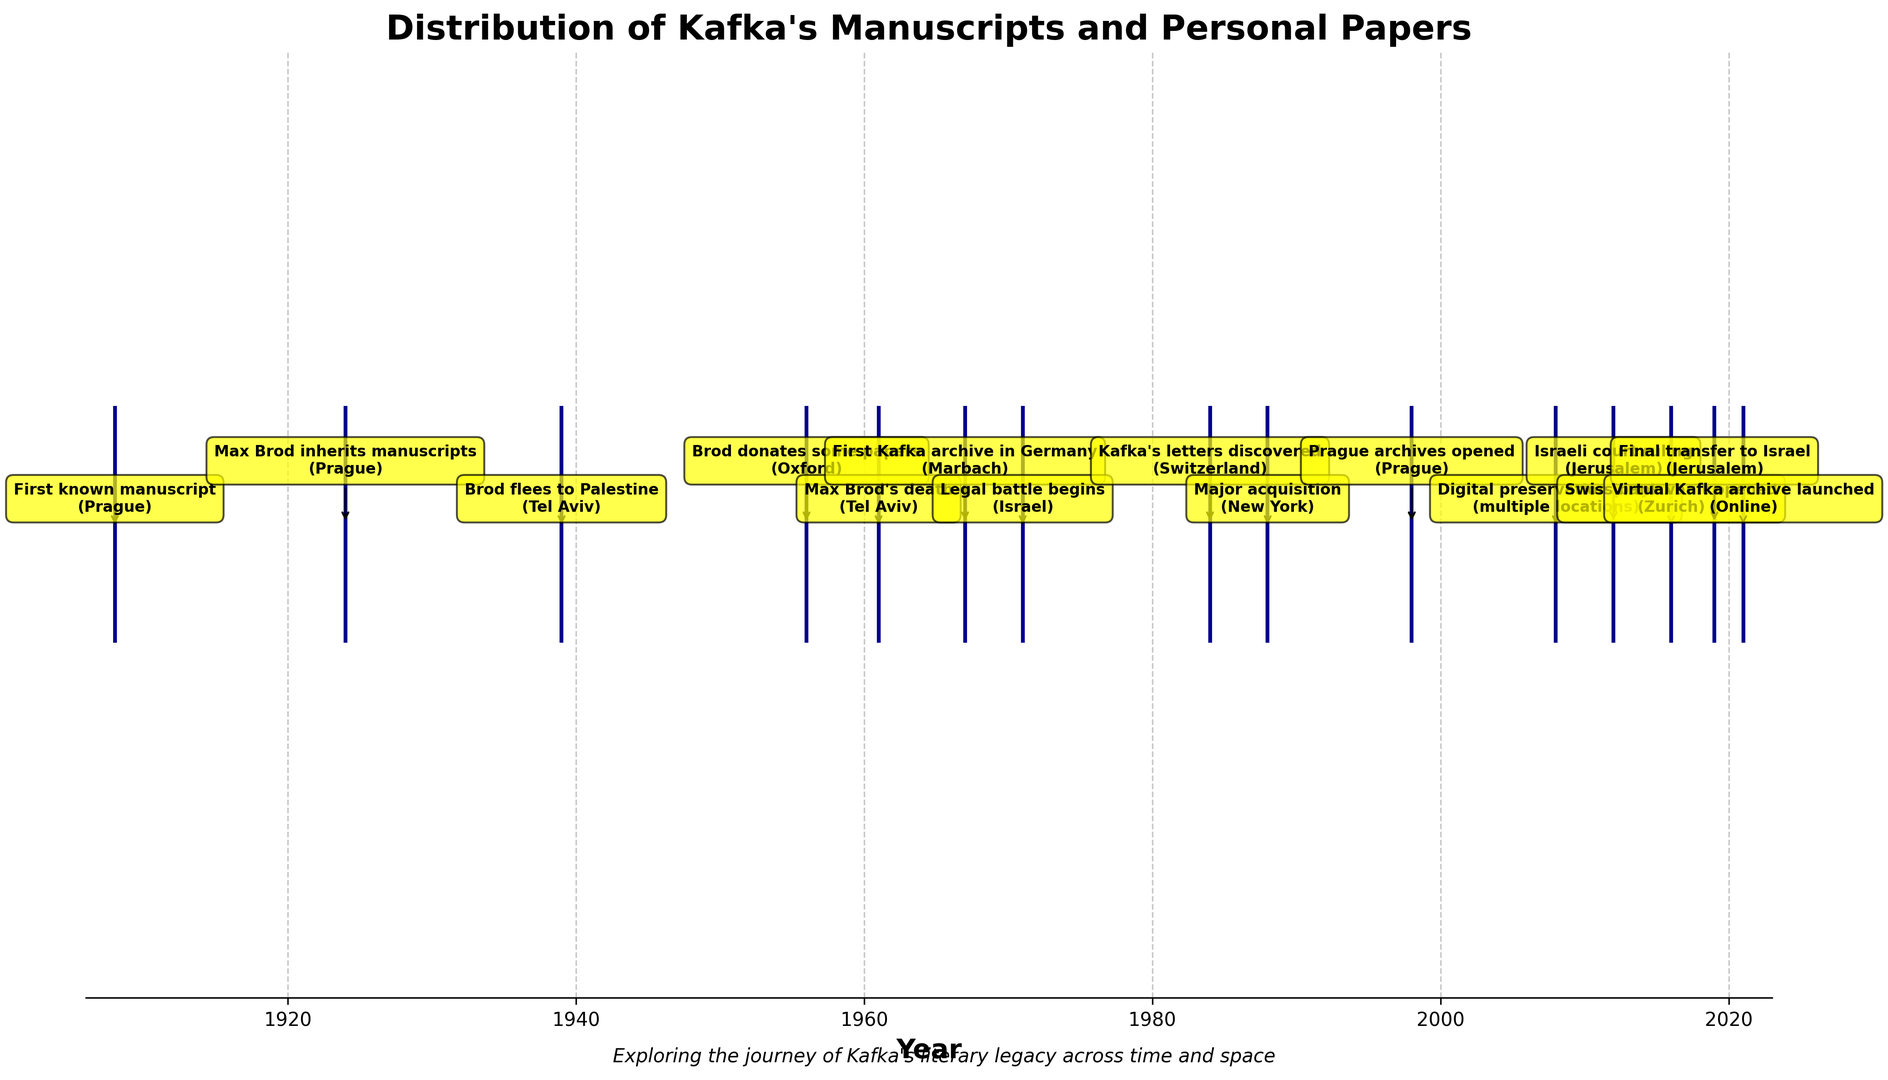What's the earliest event displayed in the figure? The label on the event line at the far left indicates the year 1908, showing "First known manuscript (Prague)." Since there is no earlier date on the figure, this is the earliest event.
Answer: 1908 What's the most recent event shown in the figure? The label on the event line at the far right points to the year 2021, indicating "Virtual Kafka archive launched (Online)." Given no later date on the figure, this is the most recent event.
Answer: 2021 How many events occurred in Tel Aviv according to the figure? Identify each event label that includes "Tel Aviv." The events are: "Brod flees to Palestine, 1939" and "Max Brod's death, 1961." Counting these, we get 2 events.
Answer: 2 Which decade saw the most events recorded on the figure? The events are marked with labels in different years. Summarize the counts by decades: 1900s (1), 1920s (1), 1930s (1), 1950s (1), 1960s (2), 1970s (1), 1980s (1), 1990s (1), 2000s (1), 2010s (3), 2020s (1). The decade with the most events is the 2010s with 3 events.
Answer: 2010s Which location has the most events associated with it? Check the location part of each label: Prague (3), Tel Aviv (2), Oxford (1), Marbach (1), Israel (1), Switzerland (1), New York (1), Jerusalem (2), Zurich (1), multiple locations (1), and Online (1). Prague has the highest number, with 3 events.
Answer: Prague Which event came directly after Kafka's manuscripts escaping Nazi confiscation? The event "Brod flees to Palestine, 1939 (Tel Aviv)" depicts the manuscripts narrowly escaping Nazi confiscation. The next chronological event on the figure is "Brod donates some papers, 1956 (Oxford)."
Answer: Brod donates some papers How many years after Max Brod's death did the legal battle over Kafka's papers begin? Max Brod died in 1961 (Tel Aviv), and the legal battle began in 1971 (Israel). The difference is 1971 - 1961 = 10 years.
Answer: 10 years What was the significance of the event that took place in New York in 1988? The label for the year 1988 indicates "Major acquisition, New York" and the significance is "Morgan Library obtains significant Kafka collection."
Answer: Morgan Library obtains significant Kafka collection What major milestone took place in 2008 regarding Kafka's works? The annotation for the year 2008 shows "Digital preservation project, multiple locations," with the significance describing an "International effort to digitize Kafka's works begins."
Answer: International effort to digitize Kafka's works begins Where were Kafka's letters discovered in 1984? According to the year label for 1984, the event "Kafka's letters discovered," took place in Switzerland.
Answer: Switzerland 